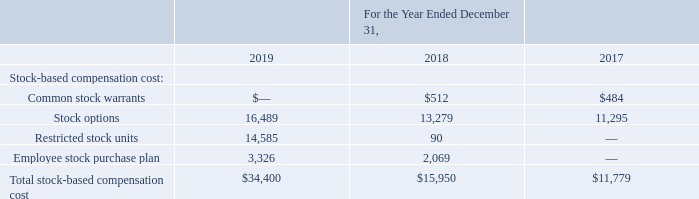Stock-Based Compensation
The Company recognized total stock-based compensation cost related to equity incentive awards as follows (in thousands):
A small portion of stock-based compensation cost above is capitalized in accordance with the accounting guidance for internal-use software. The Company uses the straight-line attribution method for recognizing stock-based compensation expense.
What are the company's respective total stock-based compensation cost in 2017 and 2018?
Answer scale should be: thousand. $11,779, $15,950. What are the company's respective total stock-based compensation cost in 2018 and 2019?
Answer scale should be: thousand. $15,950, $34,400. What are the company's respective restricted stock units between 2017 to 2019?
Answer scale should be: thousand. 0, 90, 14,585. What is the percentage change in total stock based compensation cost between 2017 and 2018?
Answer scale should be: percent. (15,950 - 11,779)/11,779 
Answer: 35.41. What is the percentage change in total stock based compensation cost between 2018 and 2019?
Answer scale should be: percent. (34,400 - 15,950)/15,950 
Answer: 115.67. What is the change in common stock warrants between 2017 and 2018?
Answer scale should be: thousand. 512 - 484 
Answer: 28. 